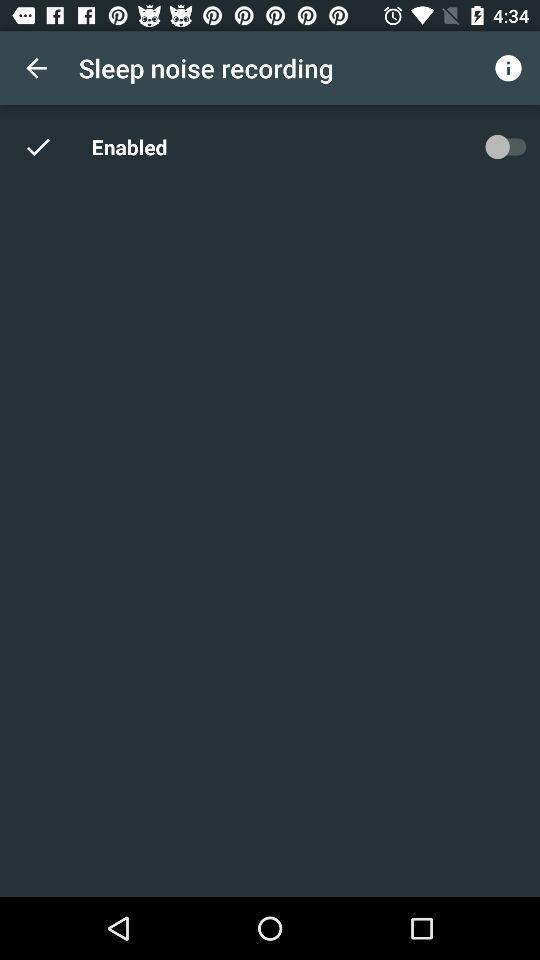How many checkmarks are displayed on the screen?
Answer the question using a single word or phrase. 1 